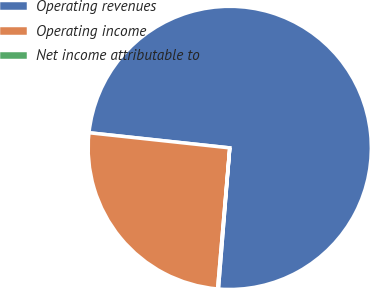Convert chart. <chart><loc_0><loc_0><loc_500><loc_500><pie_chart><fcel>Operating revenues<fcel>Operating income<fcel>Net income attributable to<nl><fcel>74.57%<fcel>25.34%<fcel>0.09%<nl></chart> 